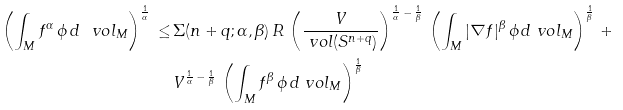<formula> <loc_0><loc_0><loc_500><loc_500>\left ( \int _ { M } f ^ { \alpha } \, \phi \, d \ v o l _ { M } \right ) ^ { \frac { 1 } { \alpha } } \, \leq \, & \Sigma ( n + q ; \alpha , \beta ) \, R \, \left ( \frac { V } { \ v o l ( S ^ { n + q } ) } \right ) ^ { { \frac { 1 } { \alpha } } \, - \, { \frac { 1 } { \beta } } } \, \left ( \int _ { M } | \nabla f | ^ { \beta } \, \phi \, d \ v o l _ { M } \right ) ^ { \frac { 1 } { \beta } } \, + \\ & V ^ { { \frac { 1 } { \alpha } } \, - \, { \frac { 1 } { \beta } } } \, \left ( \int _ { M } f ^ { \beta } \, \phi \, d \ v o l _ { M } \right ) ^ { \frac { 1 } { \beta } }</formula> 